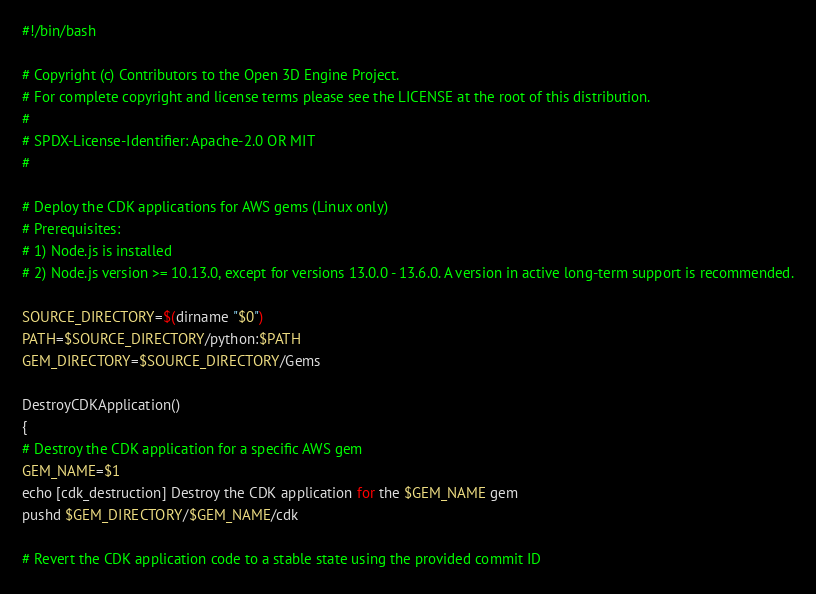Convert code to text. <code><loc_0><loc_0><loc_500><loc_500><_Bash_>#!/bin/bash

# Copyright (c) Contributors to the Open 3D Engine Project.
# For complete copyright and license terms please see the LICENSE at the root of this distribution.
#
# SPDX-License-Identifier: Apache-2.0 OR MIT
#

# Deploy the CDK applications for AWS gems (Linux only)
# Prerequisites:
# 1) Node.js is installed
# 2) Node.js version >= 10.13.0, except for versions 13.0.0 - 13.6.0. A version in active long-term support is recommended.

SOURCE_DIRECTORY=$(dirname "$0")
PATH=$SOURCE_DIRECTORY/python:$PATH
GEM_DIRECTORY=$SOURCE_DIRECTORY/Gems

DestroyCDKApplication()
{
# Destroy the CDK application for a specific AWS gem
GEM_NAME=$1
echo [cdk_destruction] Destroy the CDK application for the $GEM_NAME gem
pushd $GEM_DIRECTORY/$GEM_NAME/cdk

# Revert the CDK application code to a stable state using the provided commit ID</code> 